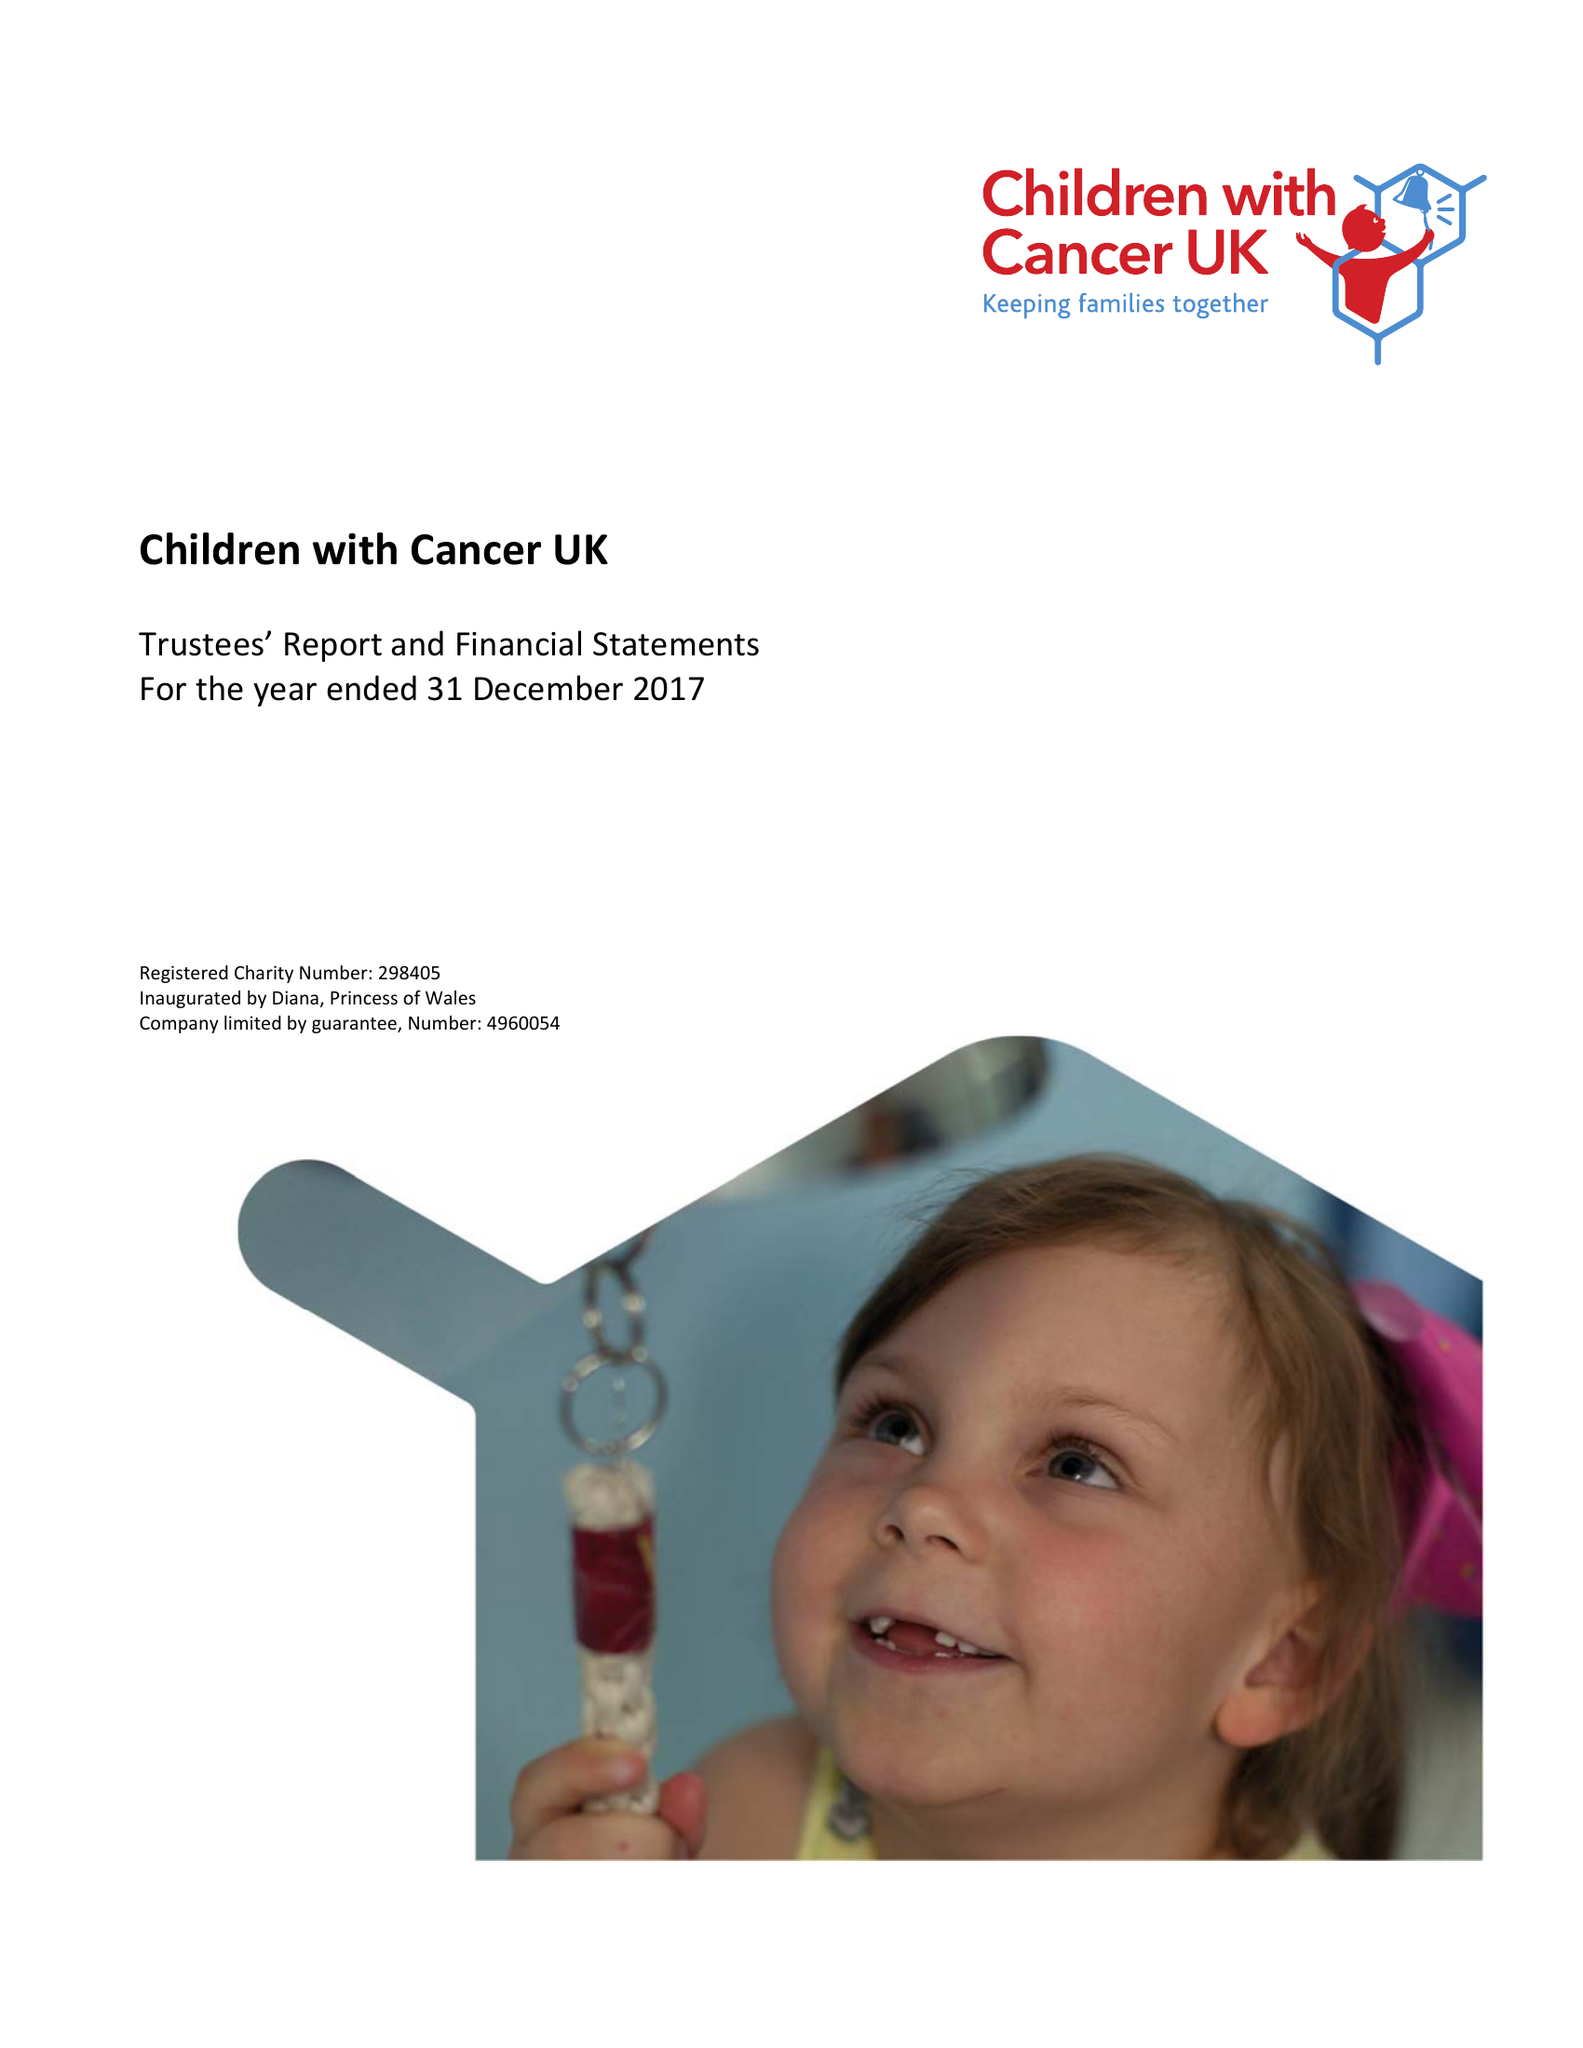What is the value for the charity_name?
Answer the question using a single word or phrase. Children With Cancer Uk 